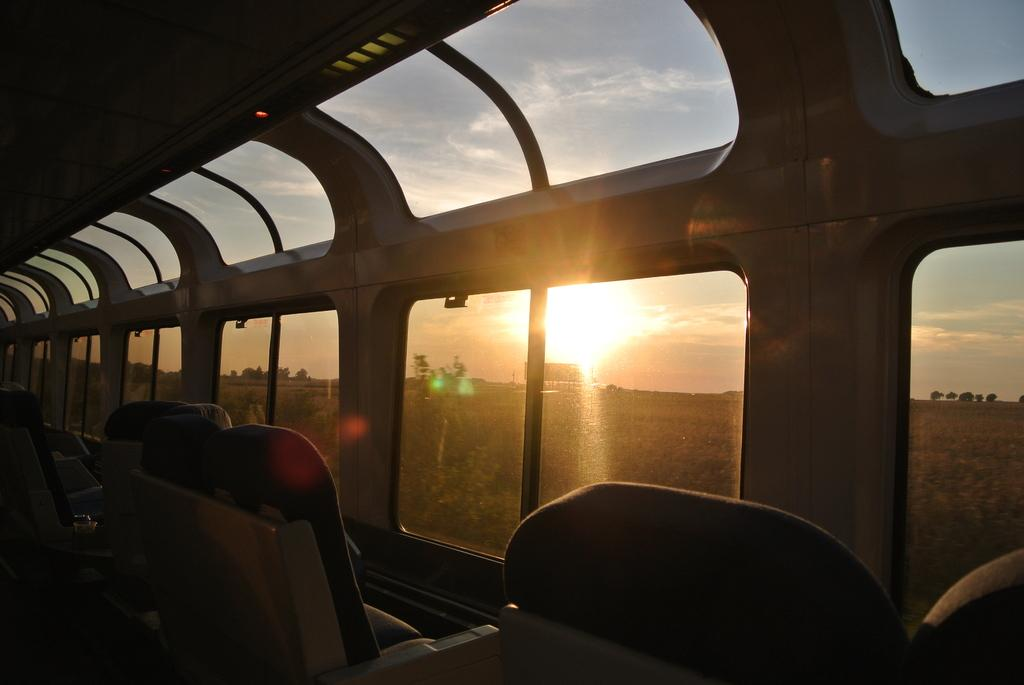What type of public transport is shown in the image? The image shows the inside view of a public transport. What can be found inside the public transport? There are seats in the public transport. What allows passengers to see outside the public transport? There are windows in the public transport. What can be seen through the windows? The sky, the sun, trees, and the land can be seen through the windows. How does the dog contribute to the comfort of the passengers in the image? There is no dog present in the image, so it cannot contribute to the comfort of the passengers. 